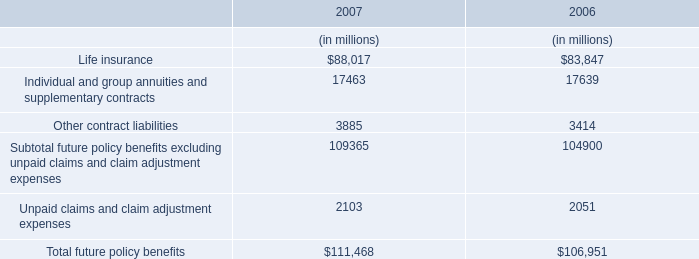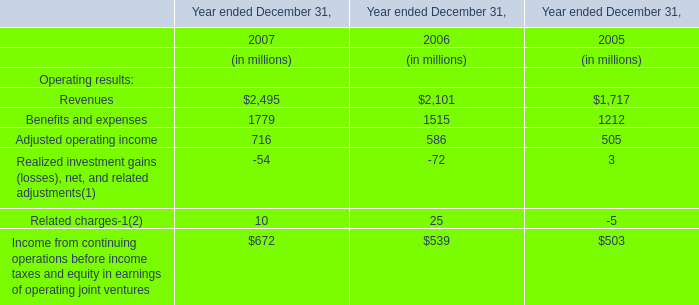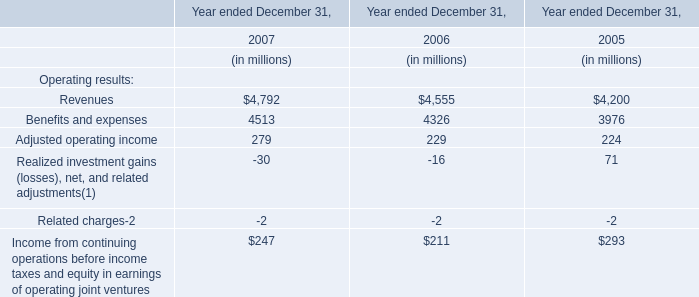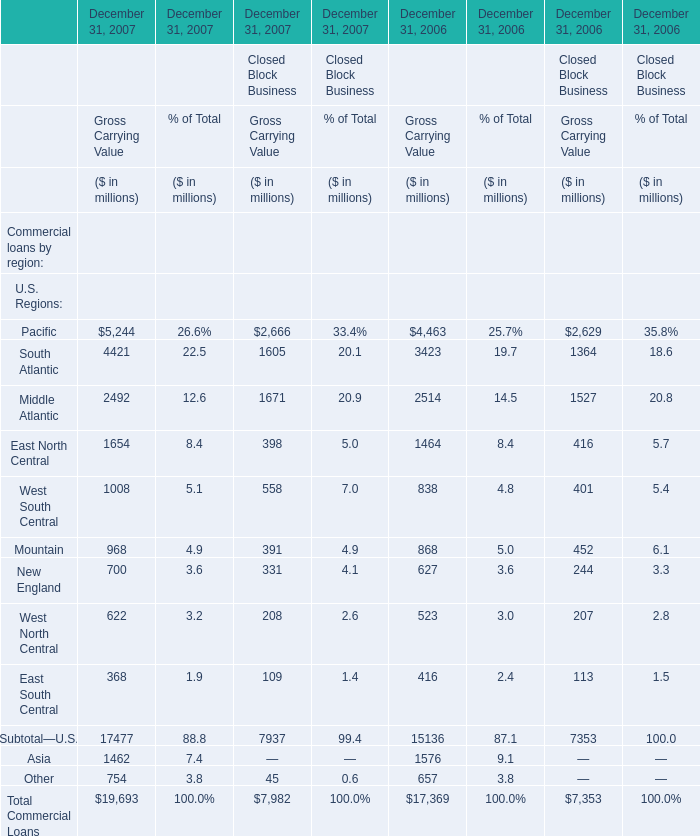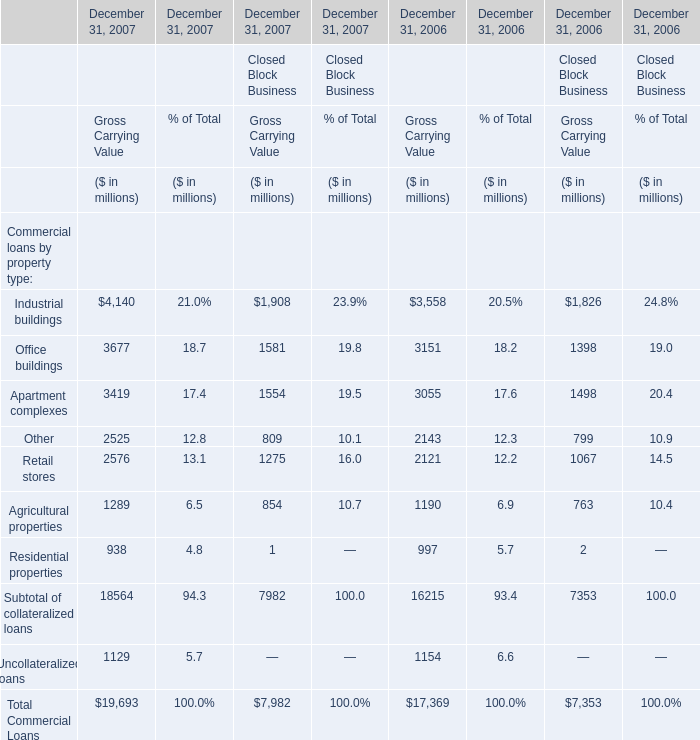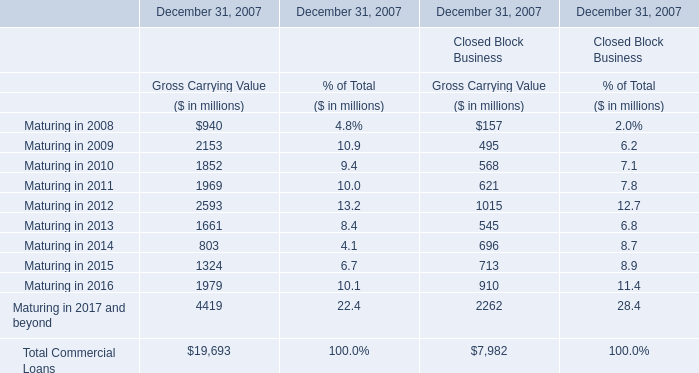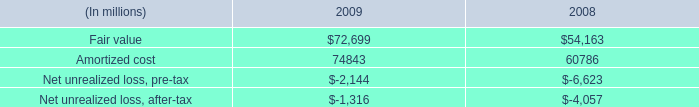Does Industrial buildings keeps increasing each year between 2006 and 2007 for Gross Carrying Value for Financial Services Businesses? 
Answer: yes. 